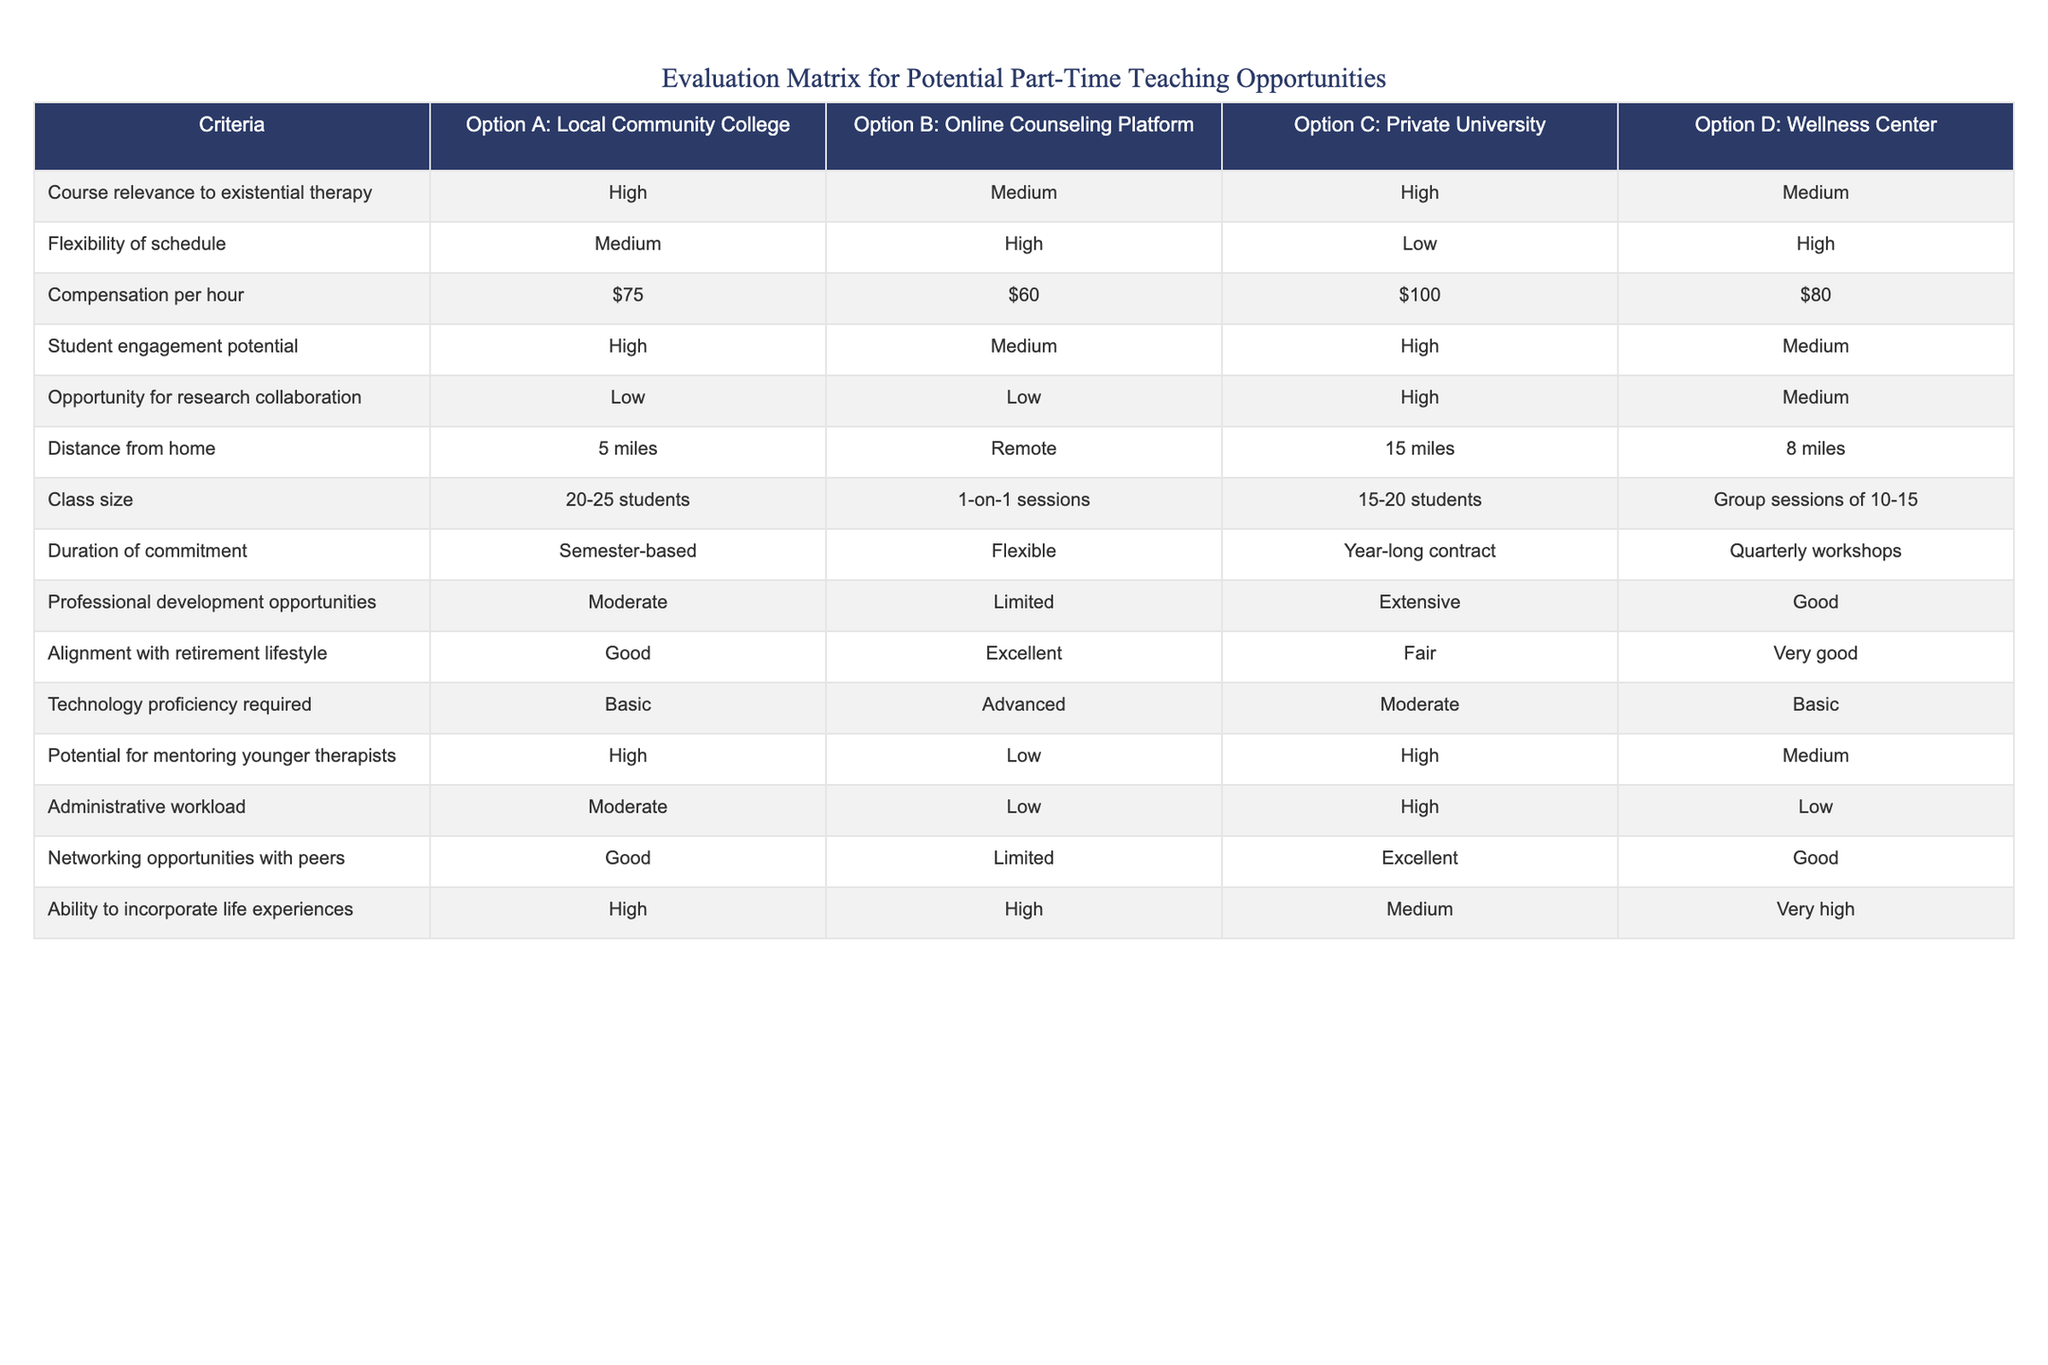What is the compensation per hour for Option C: Private University? The table lists the compensation per hour for each option. In the case of Option C: Private University, the compensation is directly stated in the corresponding row.
Answer: $100 Which options provide a high student engagement potential? The student engagement potential is categorized as High, Medium, or Low for each option. By reviewing the table, Options A and C are marked with High for student engagement potential.
Answer: Option A and Option C Which option has the most professional development opportunities? Looking at the table, the professional development opportunities are rated as Moderate, Limited, Extensive, and Good across the options. The highest rating, Extensive, is associated with Option C: Private University.
Answer: Option C Is there an opportunity for research collaboration at the Local Community College? The table shows that the opportunity for research collaboration at the Local Community College (Option A) is rated as Low. This indicates that opportunity for research collaboration is quite limited in this option.
Answer: No What is the average distance from home for the options provided? The distances from home are 5 miles, Remote (considered as 0 miles), 15 miles, and 8 miles for options A, B, C, and D, respectively. To calculate the average, first, we convert Remote to 0 and then sum these values (5 + 0 + 15 + 8) which equals 28 miles. Dividing by the number of options (4), the average distance is 28/4 = 7 miles.
Answer: 7 miles Which option has the lowest administrative workload? By examining the administrative workload ratings in the table, Options B and D are noted as having Low administrative workload.
Answer: Option B and Option D What is the difference in class size between the Wellness Center and the Private University? The class sizes for the Wellness Center (Option D) are noted as Group sessions of 10-15, and for the Private University (Option C) as 15-20 students. The difference in the minimum class sizes is 15 (Private University) - 10 (Wellness Center) = 5, and the difference in the maximum class sizes is 20 (Private University) - 15 (Wellness Center) = 5. Therefore, the difference in class size ranges from 5 to 5 students.
Answer: 5 to 5 students 